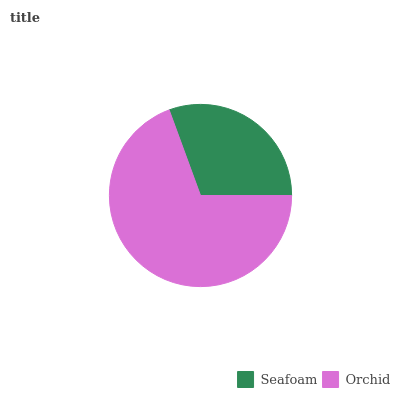Is Seafoam the minimum?
Answer yes or no. Yes. Is Orchid the maximum?
Answer yes or no. Yes. Is Orchid the minimum?
Answer yes or no. No. Is Orchid greater than Seafoam?
Answer yes or no. Yes. Is Seafoam less than Orchid?
Answer yes or no. Yes. Is Seafoam greater than Orchid?
Answer yes or no. No. Is Orchid less than Seafoam?
Answer yes or no. No. Is Orchid the high median?
Answer yes or no. Yes. Is Seafoam the low median?
Answer yes or no. Yes. Is Seafoam the high median?
Answer yes or no. No. Is Orchid the low median?
Answer yes or no. No. 